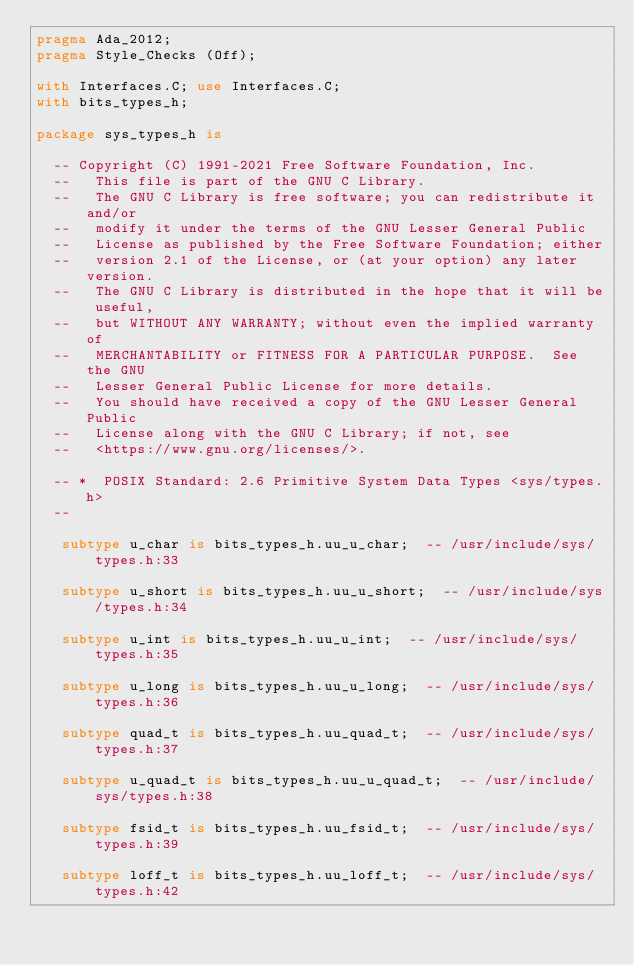Convert code to text. <code><loc_0><loc_0><loc_500><loc_500><_Ada_>pragma Ada_2012;
pragma Style_Checks (Off);

with Interfaces.C; use Interfaces.C;
with bits_types_h;

package sys_types_h is

  -- Copyright (C) 1991-2021 Free Software Foundation, Inc.
  --   This file is part of the GNU C Library.
  --   The GNU C Library is free software; you can redistribute it and/or
  --   modify it under the terms of the GNU Lesser General Public
  --   License as published by the Free Software Foundation; either
  --   version 2.1 of the License, or (at your option) any later version.
  --   The GNU C Library is distributed in the hope that it will be useful,
  --   but WITHOUT ANY WARRANTY; without even the implied warranty of
  --   MERCHANTABILITY or FITNESS FOR A PARTICULAR PURPOSE.  See the GNU
  --   Lesser General Public License for more details.
  --   You should have received a copy of the GNU Lesser General Public
  --   License along with the GNU C Library; if not, see
  --   <https://www.gnu.org/licenses/>.   

  -- *	POSIX Standard: 2.6 Primitive System Data Types	<sys/types.h>
  --  

   subtype u_char is bits_types_h.uu_u_char;  -- /usr/include/sys/types.h:33

   subtype u_short is bits_types_h.uu_u_short;  -- /usr/include/sys/types.h:34

   subtype u_int is bits_types_h.uu_u_int;  -- /usr/include/sys/types.h:35

   subtype u_long is bits_types_h.uu_u_long;  -- /usr/include/sys/types.h:36

   subtype quad_t is bits_types_h.uu_quad_t;  -- /usr/include/sys/types.h:37

   subtype u_quad_t is bits_types_h.uu_u_quad_t;  -- /usr/include/sys/types.h:38

   subtype fsid_t is bits_types_h.uu_fsid_t;  -- /usr/include/sys/types.h:39

   subtype loff_t is bits_types_h.uu_loff_t;  -- /usr/include/sys/types.h:42
</code> 